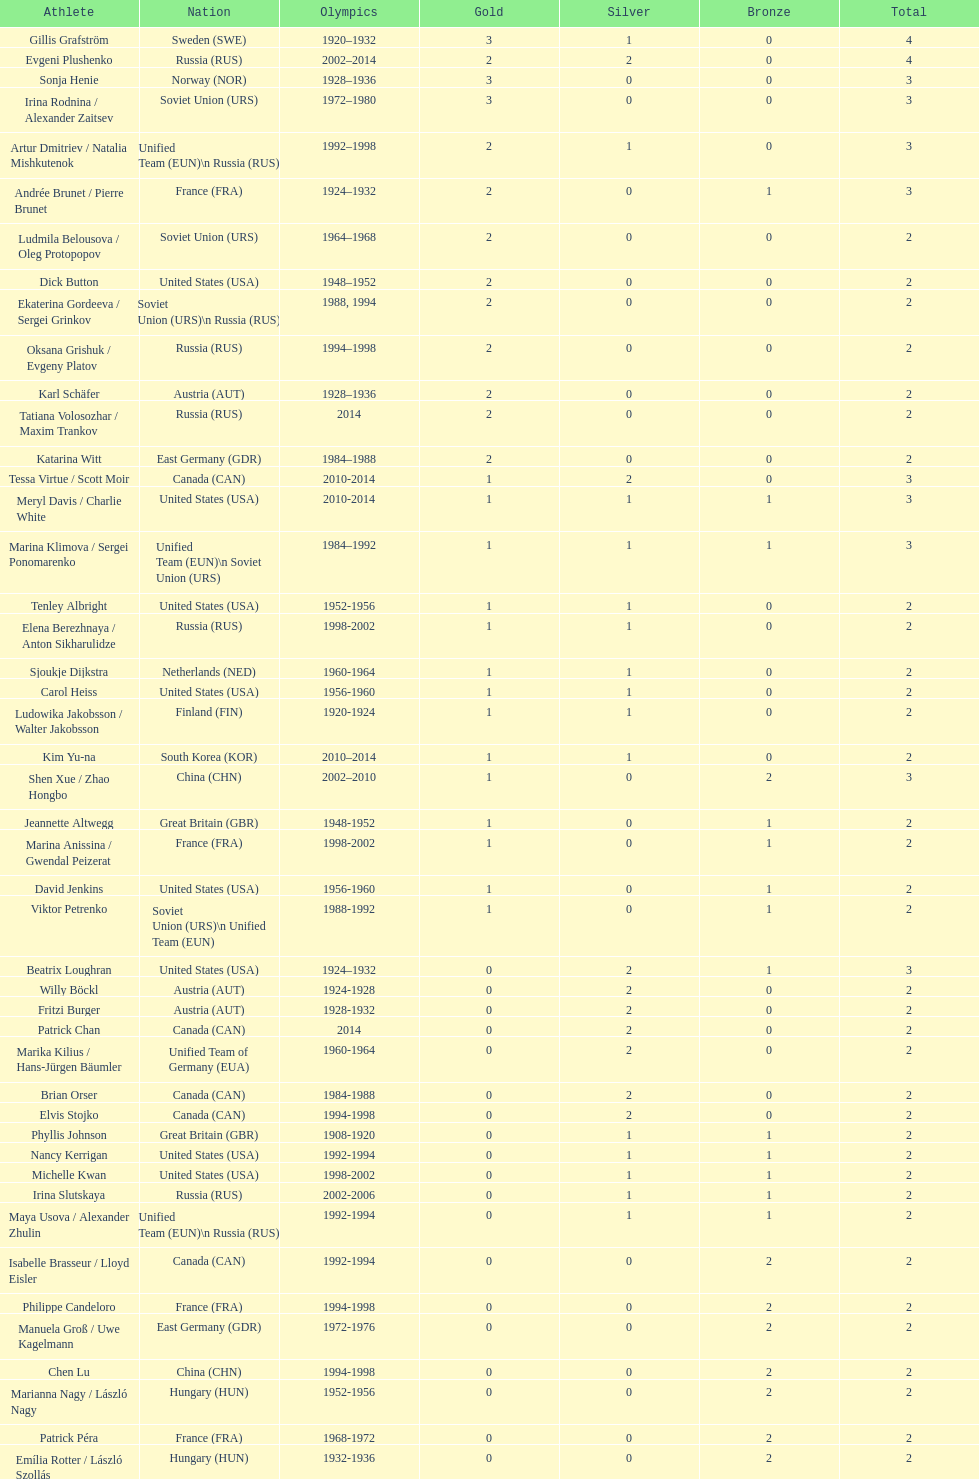Which nation first claimed three gold medals in olympic figure skating? Sweden. 